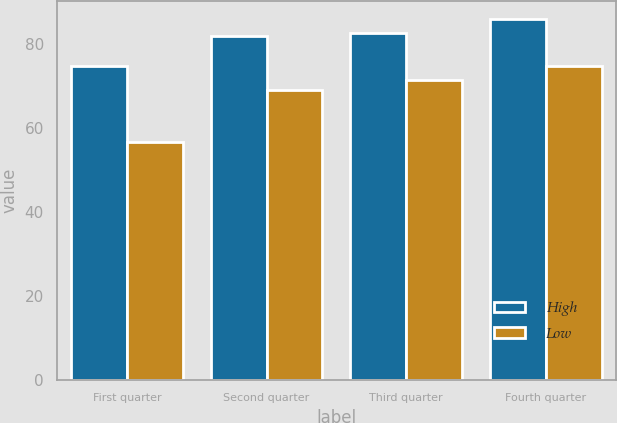Convert chart. <chart><loc_0><loc_0><loc_500><loc_500><stacked_bar_chart><ecel><fcel>First quarter<fcel>Second quarter<fcel>Third quarter<fcel>Fourth quarter<nl><fcel>High<fcel>74.7<fcel>81.92<fcel>82.59<fcel>85.97<nl><fcel>Low<fcel>56.61<fcel>69.09<fcel>71.35<fcel>74.81<nl></chart> 